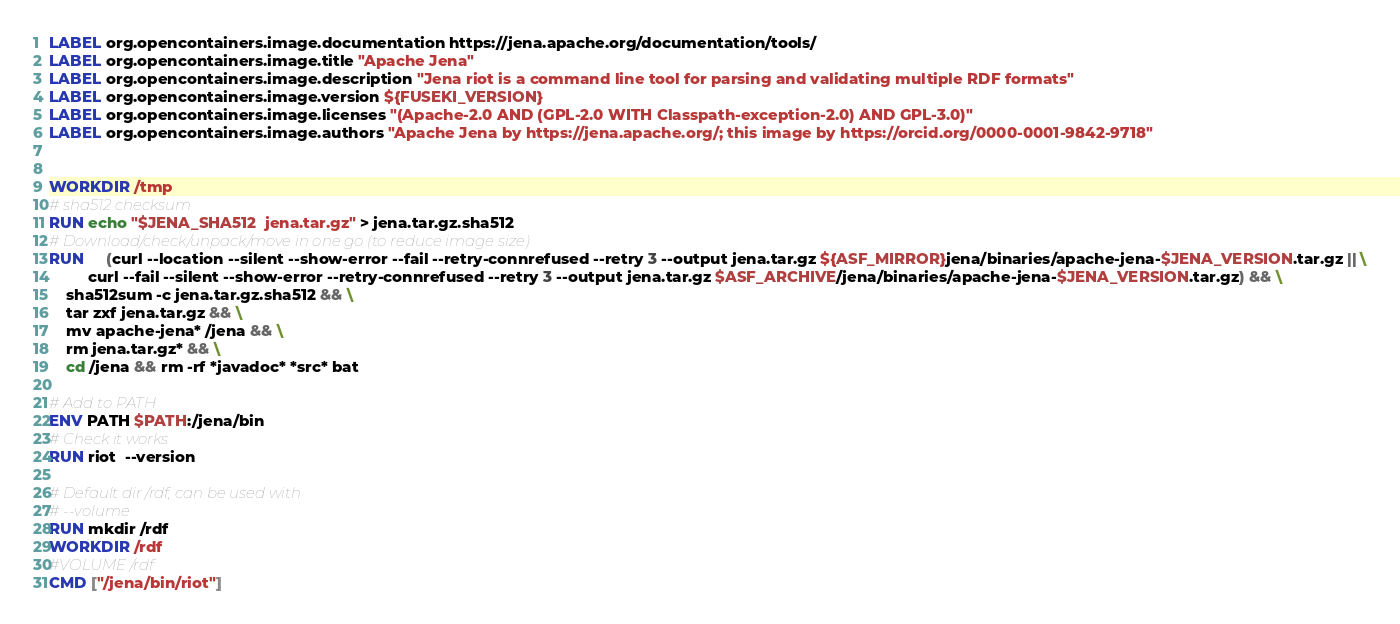Convert code to text. <code><loc_0><loc_0><loc_500><loc_500><_Dockerfile_>LABEL org.opencontainers.image.documentation https://jena.apache.org/documentation/tools/
LABEL org.opencontainers.image.title "Apache Jena"
LABEL org.opencontainers.image.description "Jena riot is a command line tool for parsing and validating multiple RDF formats"
LABEL org.opencontainers.image.version ${FUSEKI_VERSION}
LABEL org.opencontainers.image.licenses "(Apache-2.0 AND (GPL-2.0 WITH Classpath-exception-2.0) AND GPL-3.0)"
LABEL org.opencontainers.image.authors "Apache Jena by https://jena.apache.org/; this image by https://orcid.org/0000-0001-9842-9718"


WORKDIR /tmp
# sha512 checksum
RUN echo "$JENA_SHA512  jena.tar.gz" > jena.tar.gz.sha512
# Download/check/unpack/move in one go (to reduce image size)
RUN     (curl --location --silent --show-error --fail --retry-connrefused --retry 3 --output jena.tar.gz ${ASF_MIRROR}jena/binaries/apache-jena-$JENA_VERSION.tar.gz || \
         curl --fail --silent --show-error --retry-connrefused --retry 3 --output jena.tar.gz $ASF_ARCHIVE/jena/binaries/apache-jena-$JENA_VERSION.tar.gz) && \
	sha512sum -c jena.tar.gz.sha512 && \
	tar zxf jena.tar.gz && \
	mv apache-jena* /jena && \
	rm jena.tar.gz* && \
	cd /jena && rm -rf *javadoc* *src* bat

# Add to PATH
ENV PATH $PATH:/jena/bin
# Check it works
RUN riot  --version

# Default dir /rdf, can be used with
# --volume
RUN mkdir /rdf
WORKDIR /rdf
#VOLUME /rdf
CMD ["/jena/bin/riot"]
</code> 